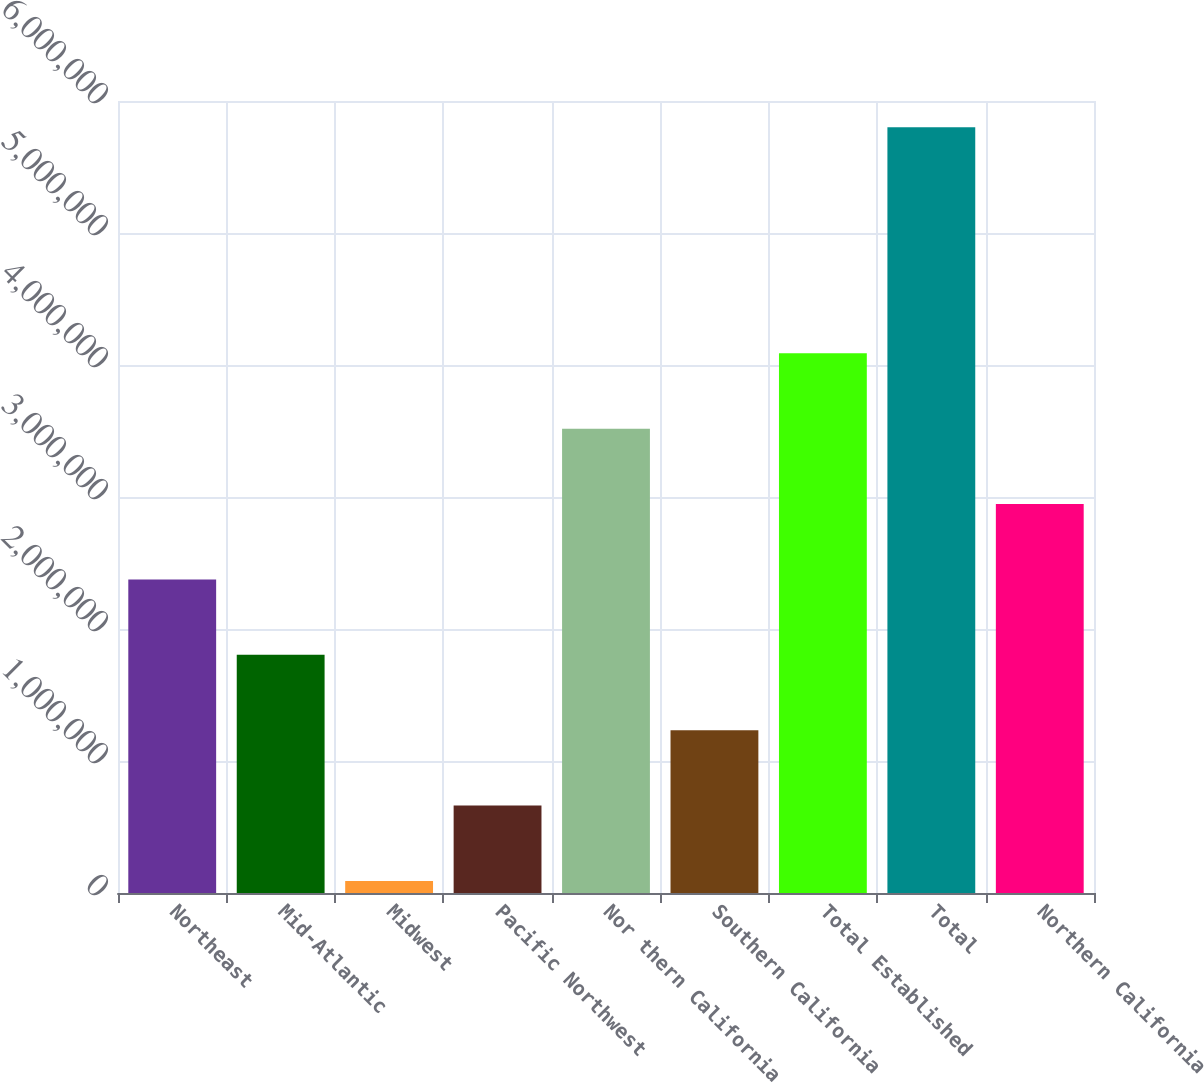Convert chart. <chart><loc_0><loc_0><loc_500><loc_500><bar_chart><fcel>Northeast<fcel>Mid-Atlantic<fcel>Midwest<fcel>Pacific Northwest<fcel>Nor thern California<fcel>Southern California<fcel>Total Established<fcel>Total<fcel>Northern California<nl><fcel>2.37577e+06<fcel>1.80477e+06<fcel>91755<fcel>662759<fcel>3.51778e+06<fcel>1.23376e+06<fcel>4.08878e+06<fcel>5.8018e+06<fcel>2.94678e+06<nl></chart> 